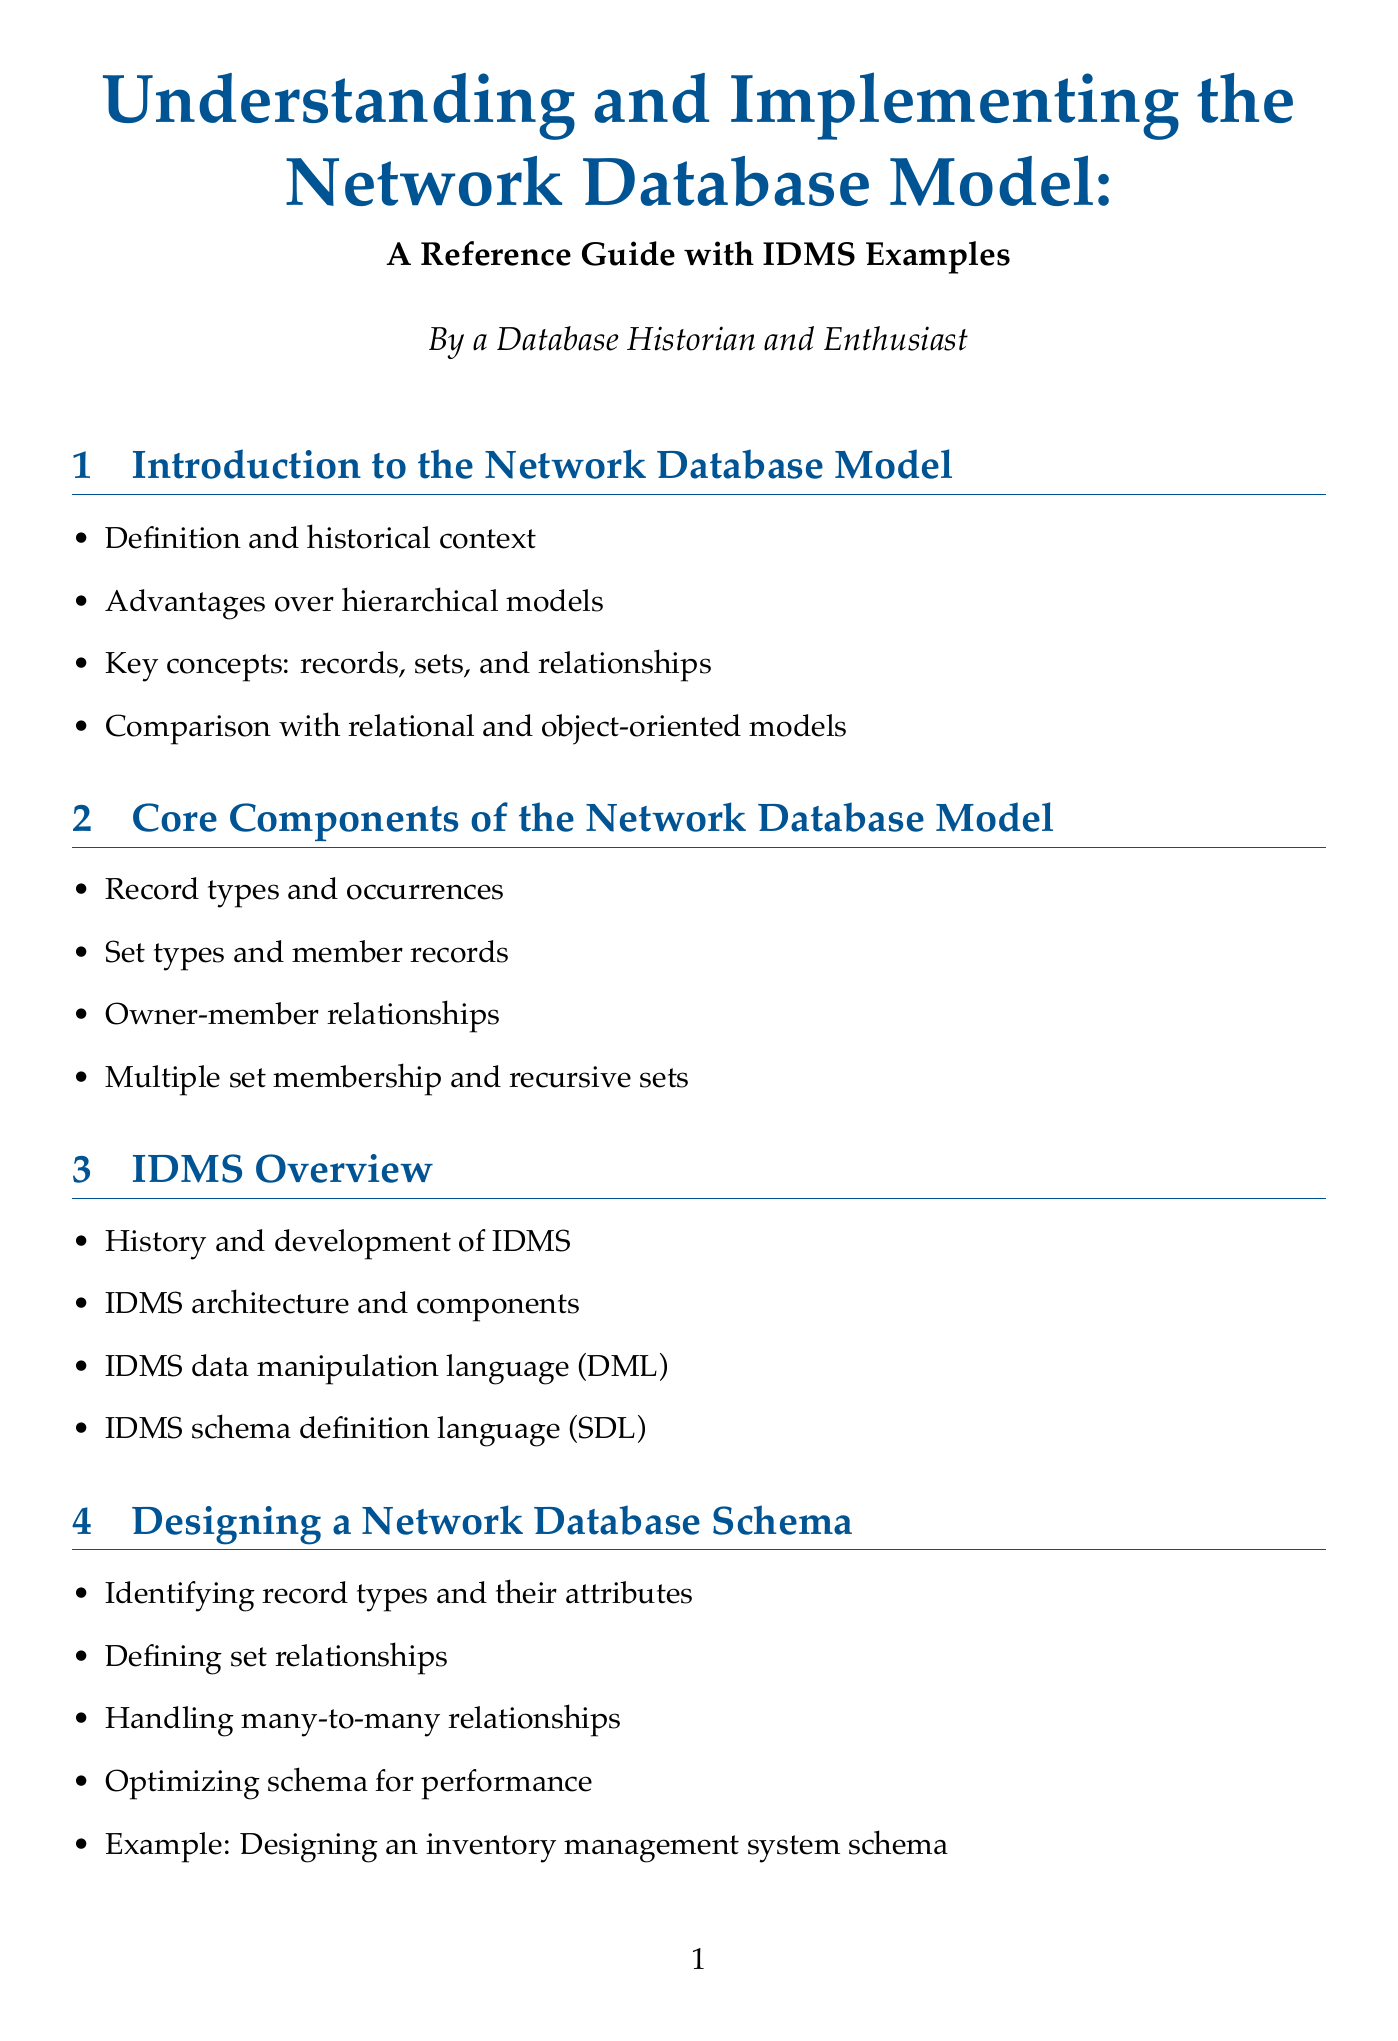What is the title of the document? The title of the document can be found prominently displayed, which is "Understanding and Implementing the Network Database Model: A Reference Guide with IDMS Examples."
Answer: Understanding and Implementing the Network Database Model: A Reference Guide with IDMS Examples What section covers IDMS architecture and components? IDMS architecture and components are discussed in the section titled "IDMS Overview."
Answer: IDMS Overview How many case studies are presented in the document? The document includes a section titled "Case Studies" which lists three specific studies.
Answer: Three What is the example schema discussed in the "Designing a Network Database Schema" section? The example schema referred to in this section is for an inventory management system.
Answer: Inventory management system Which section discusses backup and recovery strategies? Backup and recovery strategies are detailed in the section "Database Administration for Network Databases."
Answer: Database Administration for Network Databases What is a key advantage of network databases over hierarchical models? The document notes key advantages in the "Introduction to the Network Database Model" section, highlighting flexibility as a critical advantage.
Answer: Flexibility What does IDMS stand for? The acronym IDMS represents the term "Integrated Database Management System."
Answer: Integrated Database Management System What year was the IDMS implementation case study at American Airlines documented in the case studies section? The document contains case studies but does not specify the year of the American Airlines IDMS implementation; this detail is likely contextual.
Answer: Not specified 